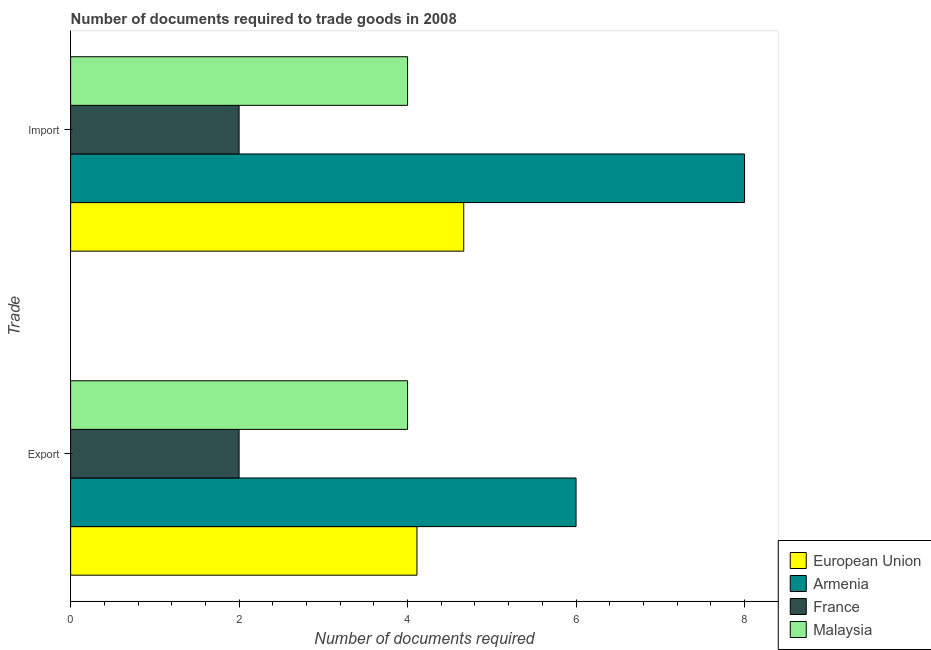How many groups of bars are there?
Ensure brevity in your answer.  2. Are the number of bars per tick equal to the number of legend labels?
Your answer should be compact. Yes. How many bars are there on the 2nd tick from the top?
Offer a terse response. 4. How many bars are there on the 2nd tick from the bottom?
Your answer should be very brief. 4. What is the label of the 1st group of bars from the top?
Your answer should be compact. Import. What is the number of documents required to export goods in Armenia?
Your answer should be compact. 6. In which country was the number of documents required to export goods maximum?
Your answer should be very brief. Armenia. In which country was the number of documents required to import goods minimum?
Provide a short and direct response. France. What is the total number of documents required to import goods in the graph?
Offer a very short reply. 18.67. What is the difference between the number of documents required to import goods in European Union and that in France?
Offer a terse response. 2.67. What is the difference between the number of documents required to export goods in France and the number of documents required to import goods in Armenia?
Give a very brief answer. -6. What is the average number of documents required to export goods per country?
Ensure brevity in your answer.  4.03. What is the difference between the number of documents required to import goods and number of documents required to export goods in European Union?
Your answer should be compact. 0.56. In how many countries, is the number of documents required to import goods greater than 2.8 ?
Your answer should be compact. 3. What is the ratio of the number of documents required to import goods in European Union to that in Malaysia?
Give a very brief answer. 1.17. Is the number of documents required to import goods in European Union less than that in France?
Give a very brief answer. No. In how many countries, is the number of documents required to export goods greater than the average number of documents required to export goods taken over all countries?
Give a very brief answer. 2. What does the 2nd bar from the top in Import represents?
Give a very brief answer. France. What does the 4th bar from the bottom in Import represents?
Make the answer very short. Malaysia. How many bars are there?
Ensure brevity in your answer.  8. How many countries are there in the graph?
Offer a very short reply. 4. Are the values on the major ticks of X-axis written in scientific E-notation?
Make the answer very short. No. Does the graph contain any zero values?
Offer a very short reply. No. Where does the legend appear in the graph?
Your answer should be very brief. Bottom right. How many legend labels are there?
Offer a terse response. 4. What is the title of the graph?
Your answer should be compact. Number of documents required to trade goods in 2008. Does "Central African Republic" appear as one of the legend labels in the graph?
Offer a very short reply. No. What is the label or title of the X-axis?
Your answer should be compact. Number of documents required. What is the label or title of the Y-axis?
Offer a terse response. Trade. What is the Number of documents required of European Union in Export?
Make the answer very short. 4.11. What is the Number of documents required in Armenia in Export?
Offer a terse response. 6. What is the Number of documents required in France in Export?
Your answer should be compact. 2. What is the Number of documents required in Malaysia in Export?
Give a very brief answer. 4. What is the Number of documents required in European Union in Import?
Your answer should be compact. 4.67. What is the Number of documents required of Armenia in Import?
Ensure brevity in your answer.  8. What is the Number of documents required of France in Import?
Provide a succinct answer. 2. What is the Number of documents required in Malaysia in Import?
Give a very brief answer. 4. Across all Trade, what is the maximum Number of documents required of European Union?
Offer a terse response. 4.67. Across all Trade, what is the minimum Number of documents required in European Union?
Ensure brevity in your answer.  4.11. What is the total Number of documents required in European Union in the graph?
Your response must be concise. 8.78. What is the total Number of documents required of Armenia in the graph?
Make the answer very short. 14. What is the difference between the Number of documents required in European Union in Export and that in Import?
Make the answer very short. -0.56. What is the difference between the Number of documents required of Malaysia in Export and that in Import?
Ensure brevity in your answer.  0. What is the difference between the Number of documents required of European Union in Export and the Number of documents required of Armenia in Import?
Ensure brevity in your answer.  -3.89. What is the difference between the Number of documents required in European Union in Export and the Number of documents required in France in Import?
Your response must be concise. 2.11. What is the difference between the Number of documents required in European Union in Export and the Number of documents required in Malaysia in Import?
Provide a succinct answer. 0.11. What is the difference between the Number of documents required in Armenia in Export and the Number of documents required in Malaysia in Import?
Ensure brevity in your answer.  2. What is the average Number of documents required of European Union per Trade?
Keep it short and to the point. 4.39. What is the average Number of documents required of Armenia per Trade?
Give a very brief answer. 7. What is the difference between the Number of documents required of European Union and Number of documents required of Armenia in Export?
Your answer should be very brief. -1.89. What is the difference between the Number of documents required of European Union and Number of documents required of France in Export?
Offer a terse response. 2.11. What is the difference between the Number of documents required in European Union and Number of documents required in Malaysia in Export?
Keep it short and to the point. 0.11. What is the difference between the Number of documents required in France and Number of documents required in Malaysia in Export?
Your answer should be compact. -2. What is the difference between the Number of documents required in European Union and Number of documents required in Armenia in Import?
Keep it short and to the point. -3.33. What is the difference between the Number of documents required of European Union and Number of documents required of France in Import?
Your answer should be compact. 2.67. What is the ratio of the Number of documents required of European Union in Export to that in Import?
Ensure brevity in your answer.  0.88. What is the ratio of the Number of documents required of France in Export to that in Import?
Your answer should be compact. 1. What is the ratio of the Number of documents required of Malaysia in Export to that in Import?
Provide a succinct answer. 1. What is the difference between the highest and the second highest Number of documents required of European Union?
Offer a very short reply. 0.56. What is the difference between the highest and the second highest Number of documents required in Armenia?
Offer a terse response. 2. What is the difference between the highest and the second highest Number of documents required in France?
Provide a short and direct response. 0. What is the difference between the highest and the second highest Number of documents required in Malaysia?
Your answer should be compact. 0. What is the difference between the highest and the lowest Number of documents required in European Union?
Offer a terse response. 0.56. What is the difference between the highest and the lowest Number of documents required in Armenia?
Offer a very short reply. 2. What is the difference between the highest and the lowest Number of documents required in Malaysia?
Make the answer very short. 0. 